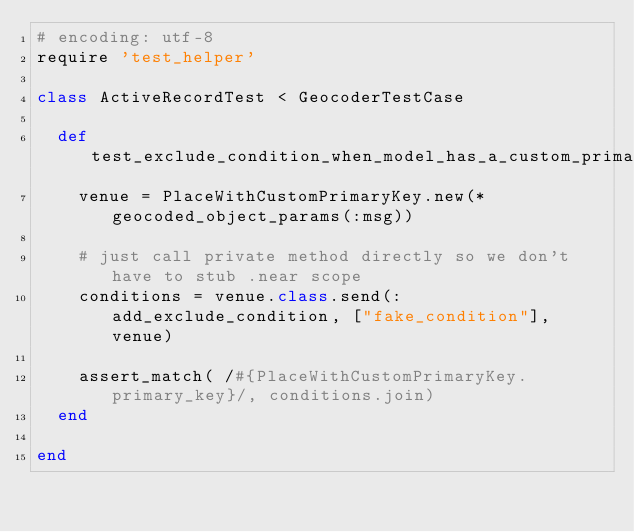<code> <loc_0><loc_0><loc_500><loc_500><_Ruby_># encoding: utf-8
require 'test_helper'

class ActiveRecordTest < GeocoderTestCase

  def test_exclude_condition_when_model_has_a_custom_primary_key
    venue = PlaceWithCustomPrimaryKey.new(*geocoded_object_params(:msg))

    # just call private method directly so we don't have to stub .near scope
    conditions = venue.class.send(:add_exclude_condition, ["fake_condition"], venue)

    assert_match( /#{PlaceWithCustomPrimaryKey.primary_key}/, conditions.join)
  end

end
</code> 